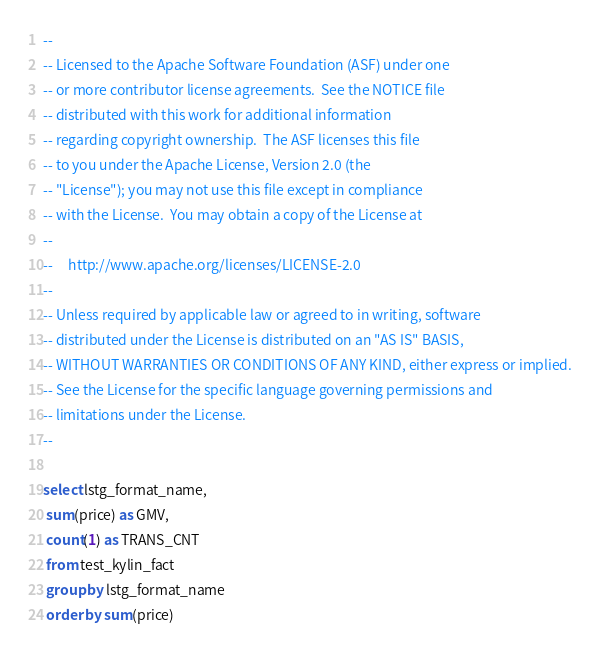Convert code to text. <code><loc_0><loc_0><loc_500><loc_500><_SQL_>--
-- Licensed to the Apache Software Foundation (ASF) under one
-- or more contributor license agreements.  See the NOTICE file
-- distributed with this work for additional information
-- regarding copyright ownership.  The ASF licenses this file
-- to you under the Apache License, Version 2.0 (the
-- "License"); you may not use this file except in compliance
-- with the License.  You may obtain a copy of the License at
--
--     http://www.apache.org/licenses/LICENSE-2.0
--
-- Unless required by applicable law or agreed to in writing, software
-- distributed under the License is distributed on an "AS IS" BASIS,
-- WITHOUT WARRANTIES OR CONDITIONS OF ANY KIND, either express or implied.
-- See the License for the specific language governing permissions and
-- limitations under the License.
--

select lstg_format_name, 
 sum(price) as GMV, 
 count(1) as TRANS_CNT 
 from test_kylin_fact 
 group by lstg_format_name 
 order by sum(price)
</code> 